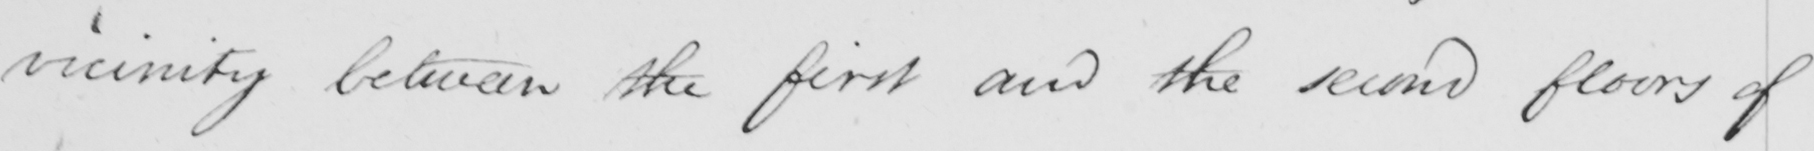What is written in this line of handwriting? vicinity between the first and the second floors of 